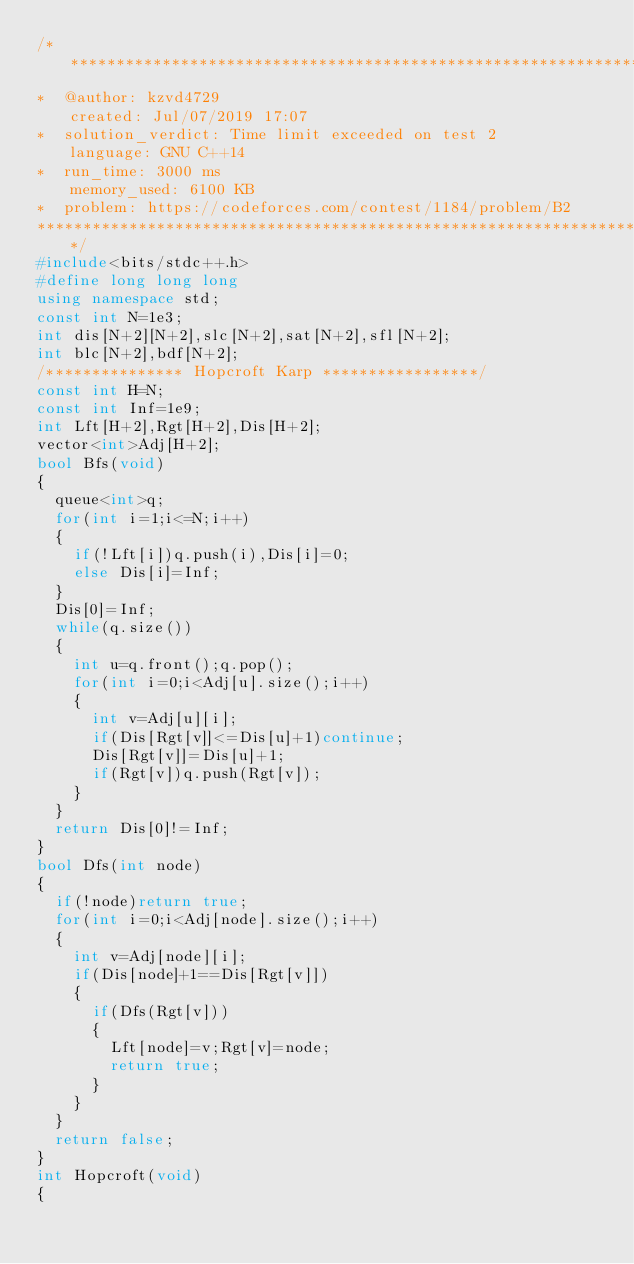Convert code to text. <code><loc_0><loc_0><loc_500><loc_500><_C++_>/****************************************************************************************
*  @author: kzvd4729                                         created: Jul/07/2019 17:07                        
*  solution_verdict: Time limit exceeded on test 2           language: GNU C++14                               
*  run_time: 3000 ms                                         memory_used: 6100 KB                              
*  problem: https://codeforces.com/contest/1184/problem/B2
****************************************************************************************/
#include<bits/stdc++.h>
#define long long long
using namespace std;
const int N=1e3;
int dis[N+2][N+2],slc[N+2],sat[N+2],sfl[N+2];
int blc[N+2],bdf[N+2];
/*************** Hopcroft Karp *****************/
const int H=N;
const int Inf=1e9;
int Lft[H+2],Rgt[H+2],Dis[H+2];
vector<int>Adj[H+2];
bool Bfs(void)
{
  queue<int>q;
  for(int i=1;i<=N;i++)
  {
    if(!Lft[i])q.push(i),Dis[i]=0;
    else Dis[i]=Inf;
  }
  Dis[0]=Inf;
  while(q.size())
  {
    int u=q.front();q.pop();
    for(int i=0;i<Adj[u].size();i++)
    {
      int v=Adj[u][i];
      if(Dis[Rgt[v]]<=Dis[u]+1)continue;
      Dis[Rgt[v]]=Dis[u]+1;
      if(Rgt[v])q.push(Rgt[v]);
    }
  }
  return Dis[0]!=Inf;
}
bool Dfs(int node)
{
  if(!node)return true;
  for(int i=0;i<Adj[node].size();i++)
  {
    int v=Adj[node][i];
    if(Dis[node]+1==Dis[Rgt[v]])
    {
      if(Dfs(Rgt[v]))
      {
        Lft[node]=v;Rgt[v]=node;
        return true;
      }
    }
  }
  return false;
}
int Hopcroft(void)
{</code> 